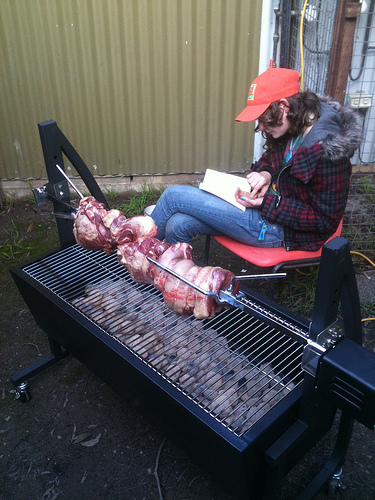<image>
Is there a hat in the grill? No. The hat is not contained within the grill. These objects have a different spatial relationship. Is the meat in front of the lady? Yes. The meat is positioned in front of the lady, appearing closer to the camera viewpoint. 